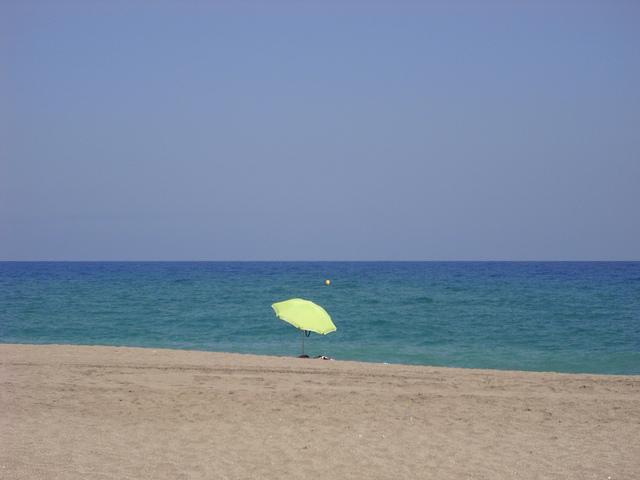How many suitcases are in the picture?
Give a very brief answer. 0. 